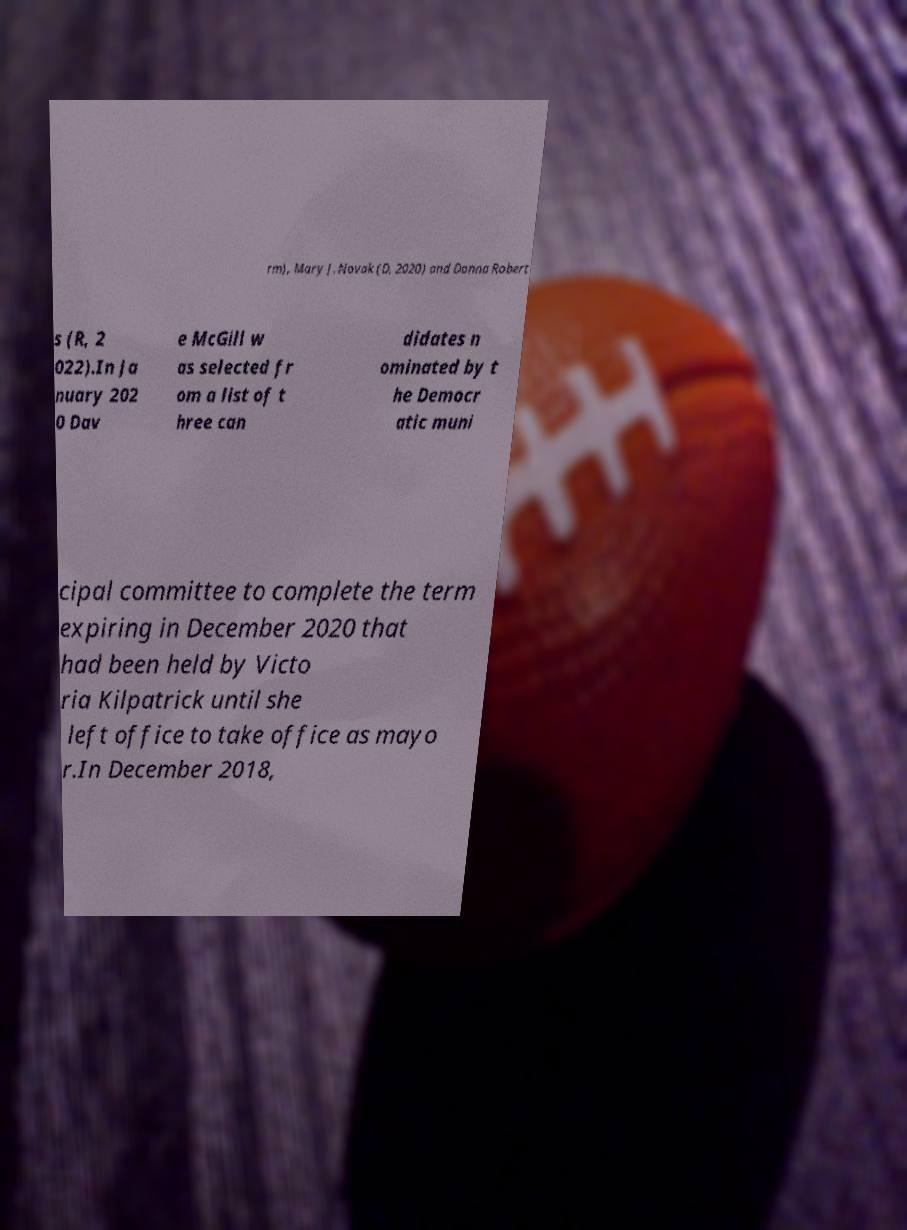Please identify and transcribe the text found in this image. rm), Mary J. Novak (D, 2020) and Donna Robert s (R, 2 022).In Ja nuary 202 0 Dav e McGill w as selected fr om a list of t hree can didates n ominated by t he Democr atic muni cipal committee to complete the term expiring in December 2020 that had been held by Victo ria Kilpatrick until she left office to take office as mayo r.In December 2018, 